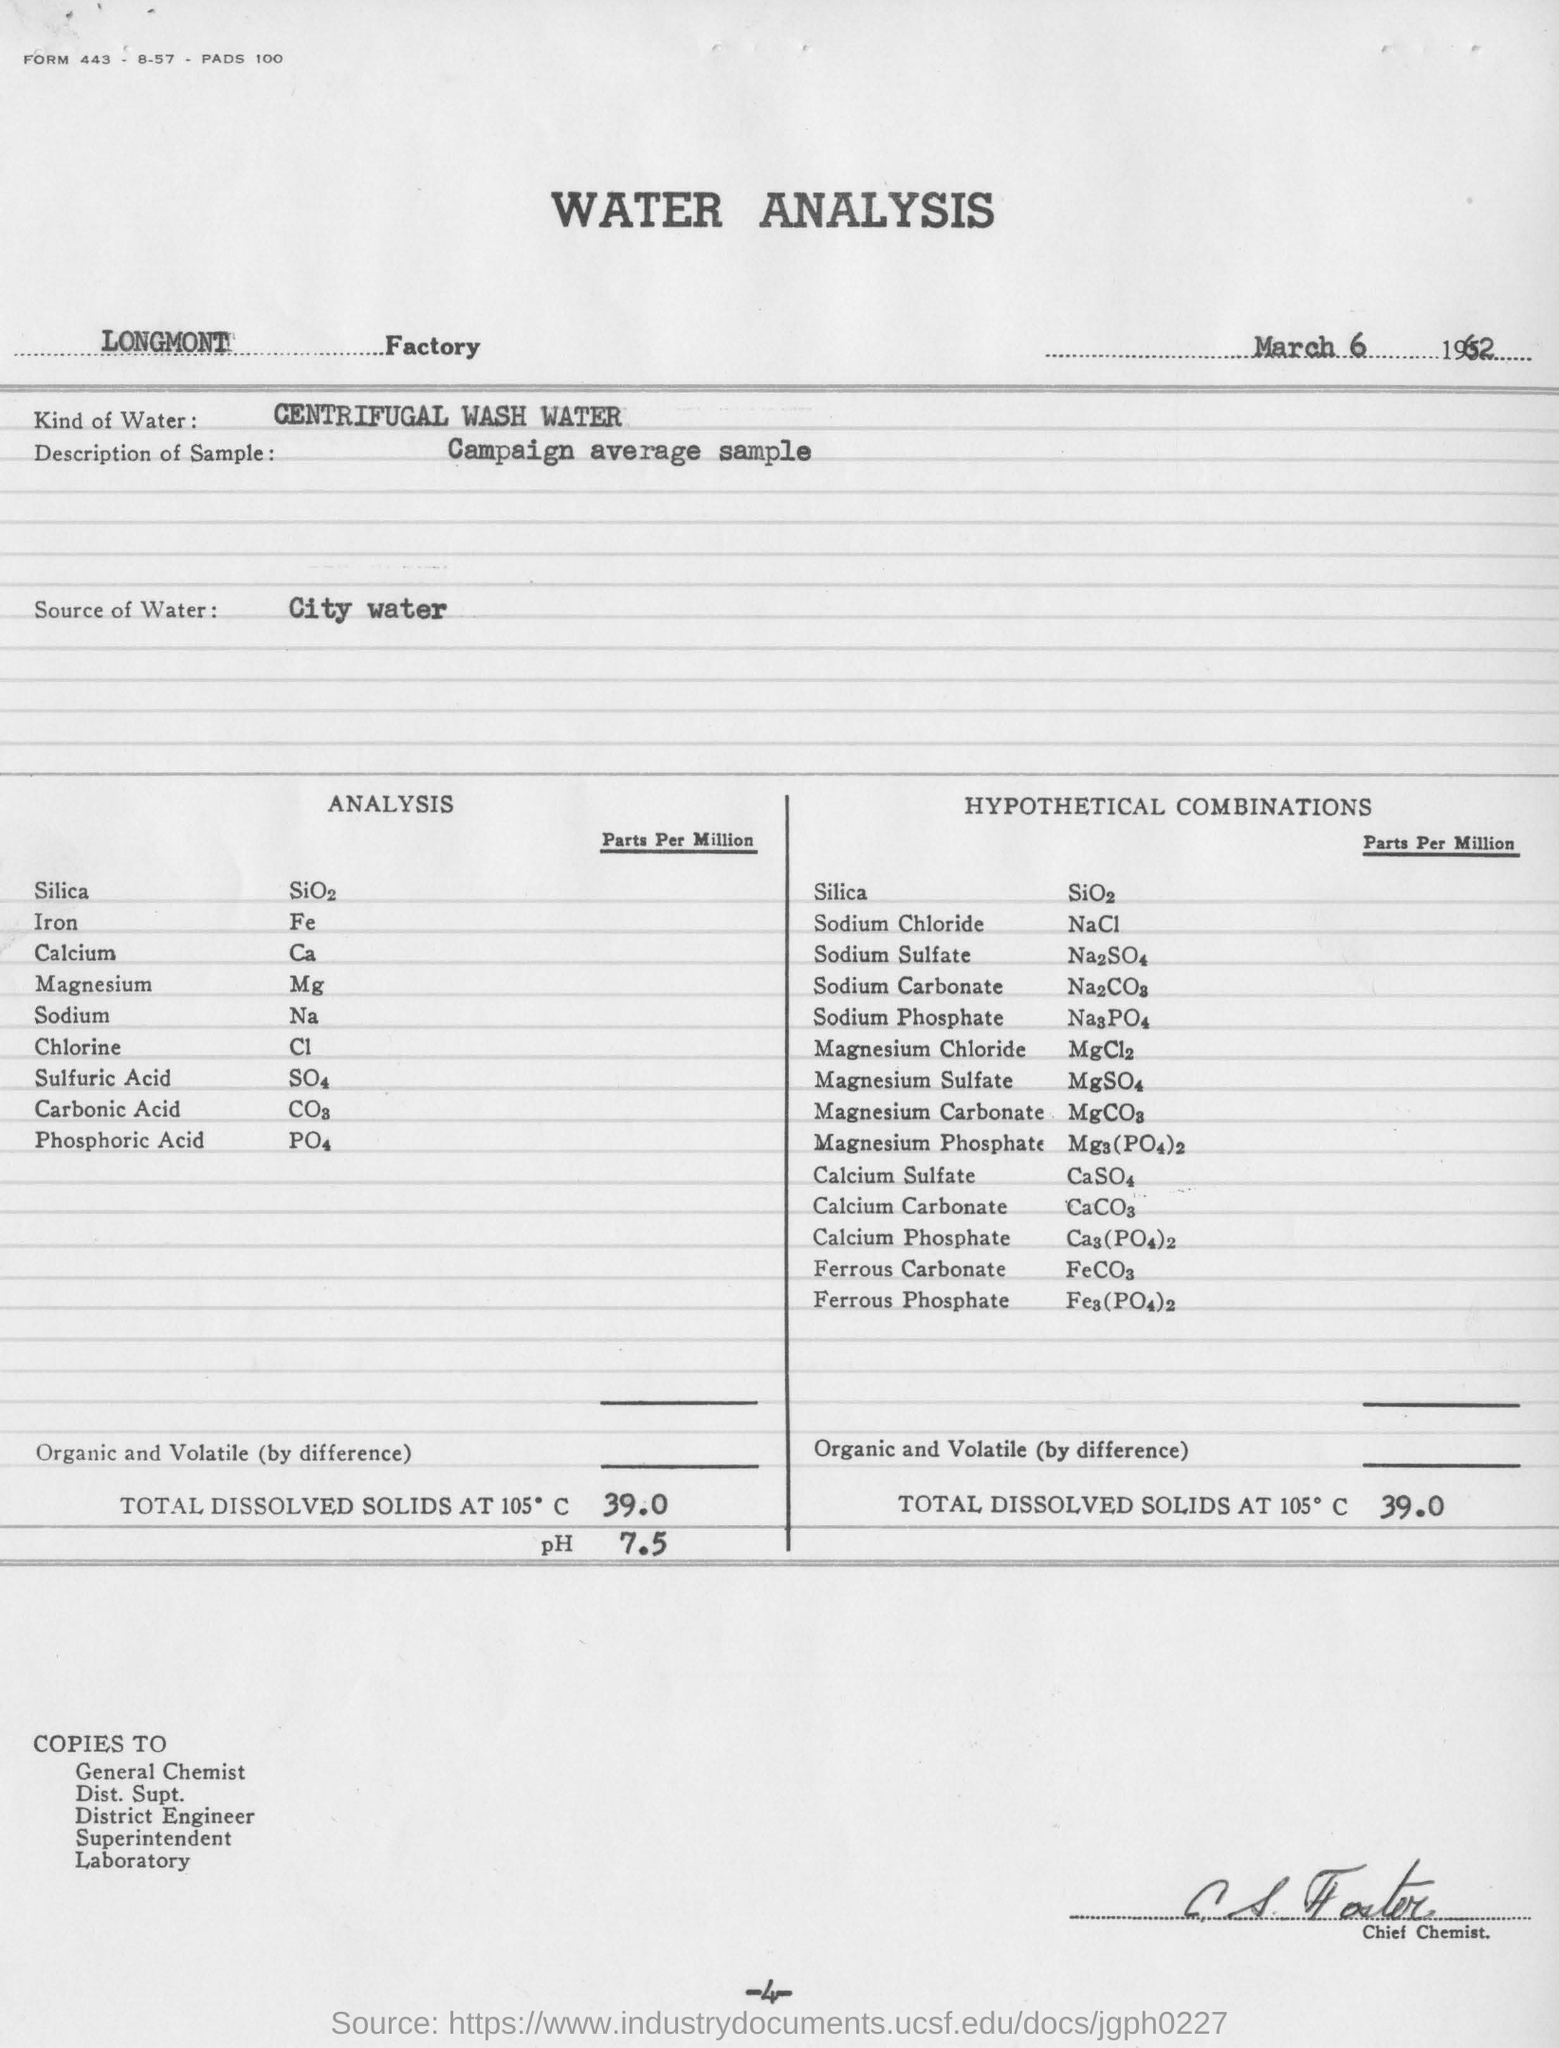Draw attention to some important aspects in this diagram. Iron is a chemical element with the symbol Fe and atomic number 26. It is a metal that is commonly found in the Earth's crust and is a key component of the planet's geological history. Iron is an essential nutrient for many living organisms and plays a vital role in the functioning of the human body. The chemical formula for calcium is Ca, which is a chemical symbol used to represent the element calcium. Centrifugal wash water shall be used. Chlorine is a chemical element represented by the symbol Cl and atomic number 17. It is a highly reactive nonmetal that is typically colorless, odorless, and tasteless. Chlorine is often used as a disinfectant and a bleaching agent, and it is also a key component in the production of various chemicals and plastics. In its pure form, chlorine is a gas at room temperature, but it can also exist as a liquid or a solid depending on the temperature and pressure. The date mentioned at the top of the document is March 6, 1962. 